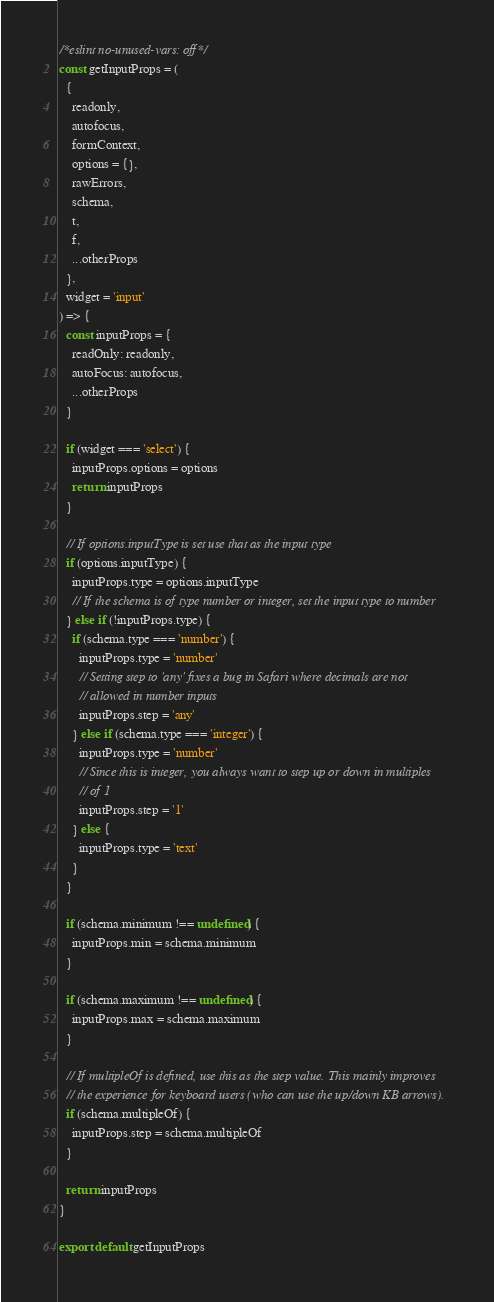Convert code to text. <code><loc_0><loc_0><loc_500><loc_500><_JavaScript_>/*eslint no-unused-vars: off*/
const getInputProps = (
  {
    readonly,
    autofocus,
    formContext,
    options = {},
    rawErrors,
    schema,
    t,
    f,
    ...otherProps
  },
  widget = 'input'
) => {
  const inputProps = {
    readOnly: readonly,
    autoFocus: autofocus,
    ...otherProps
  }

  if (widget === 'select') {
    inputProps.options = options
    return inputProps
  }

  // If options.inputType is set use that as the input type
  if (options.inputType) {
    inputProps.type = options.inputType
    // If the schema is of type number or integer, set the input type to number
  } else if (!inputProps.type) {
    if (schema.type === 'number') {
      inputProps.type = 'number'
      // Setting step to 'any' fixes a bug in Safari where decimals are not
      // allowed in number inputs
      inputProps.step = 'any'
    } else if (schema.type === 'integer') {
      inputProps.type = 'number'
      // Since this is integer, you always want to step up or down in multiples
      // of 1
      inputProps.step = '1'
    } else {
      inputProps.type = 'text'
    }
  }

  if (schema.minimum !== undefined) {
    inputProps.min = schema.minimum
  }

  if (schema.maximum !== undefined) {
    inputProps.max = schema.maximum
  }

  // If multipleOf is defined, use this as the step value. This mainly improves
  // the experience for keyboard users (who can use the up/down KB arrows).
  if (schema.multipleOf) {
    inputProps.step = schema.multipleOf
  }

  return inputProps
}

export default getInputProps
</code> 